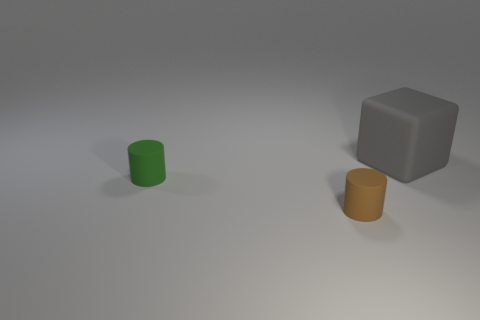How many cubes are green matte objects or tiny matte objects?
Offer a very short reply. 0. How many things are either gray blocks or things on the left side of the large gray rubber block?
Give a very brief answer. 3. Is there a tiny gray matte cylinder?
Your answer should be compact. No. What number of matte cubes are the same color as the big rubber object?
Provide a short and direct response. 0. What size is the cylinder that is on the right side of the rubber cylinder that is behind the small brown cylinder?
Provide a short and direct response. Small. Is there a large cyan object made of the same material as the tiny green object?
Keep it short and to the point. No. What is the material of the thing that is the same size as the green cylinder?
Make the answer very short. Rubber. There is a tiny cylinder that is right of the green thing; does it have the same color as the small cylinder that is behind the tiny brown matte cylinder?
Offer a terse response. No. There is a small cylinder in front of the small green rubber object; are there any green things to the right of it?
Your answer should be compact. No. Does the tiny thing to the left of the brown cylinder have the same shape as the object that is behind the tiny green rubber thing?
Offer a very short reply. No. 